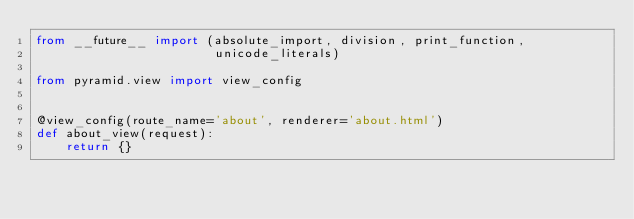Convert code to text. <code><loc_0><loc_0><loc_500><loc_500><_Python_>from __future__ import (absolute_import, division, print_function,
                        unicode_literals)

from pyramid.view import view_config


@view_config(route_name='about', renderer='about.html')
def about_view(request):
    return {}
</code> 